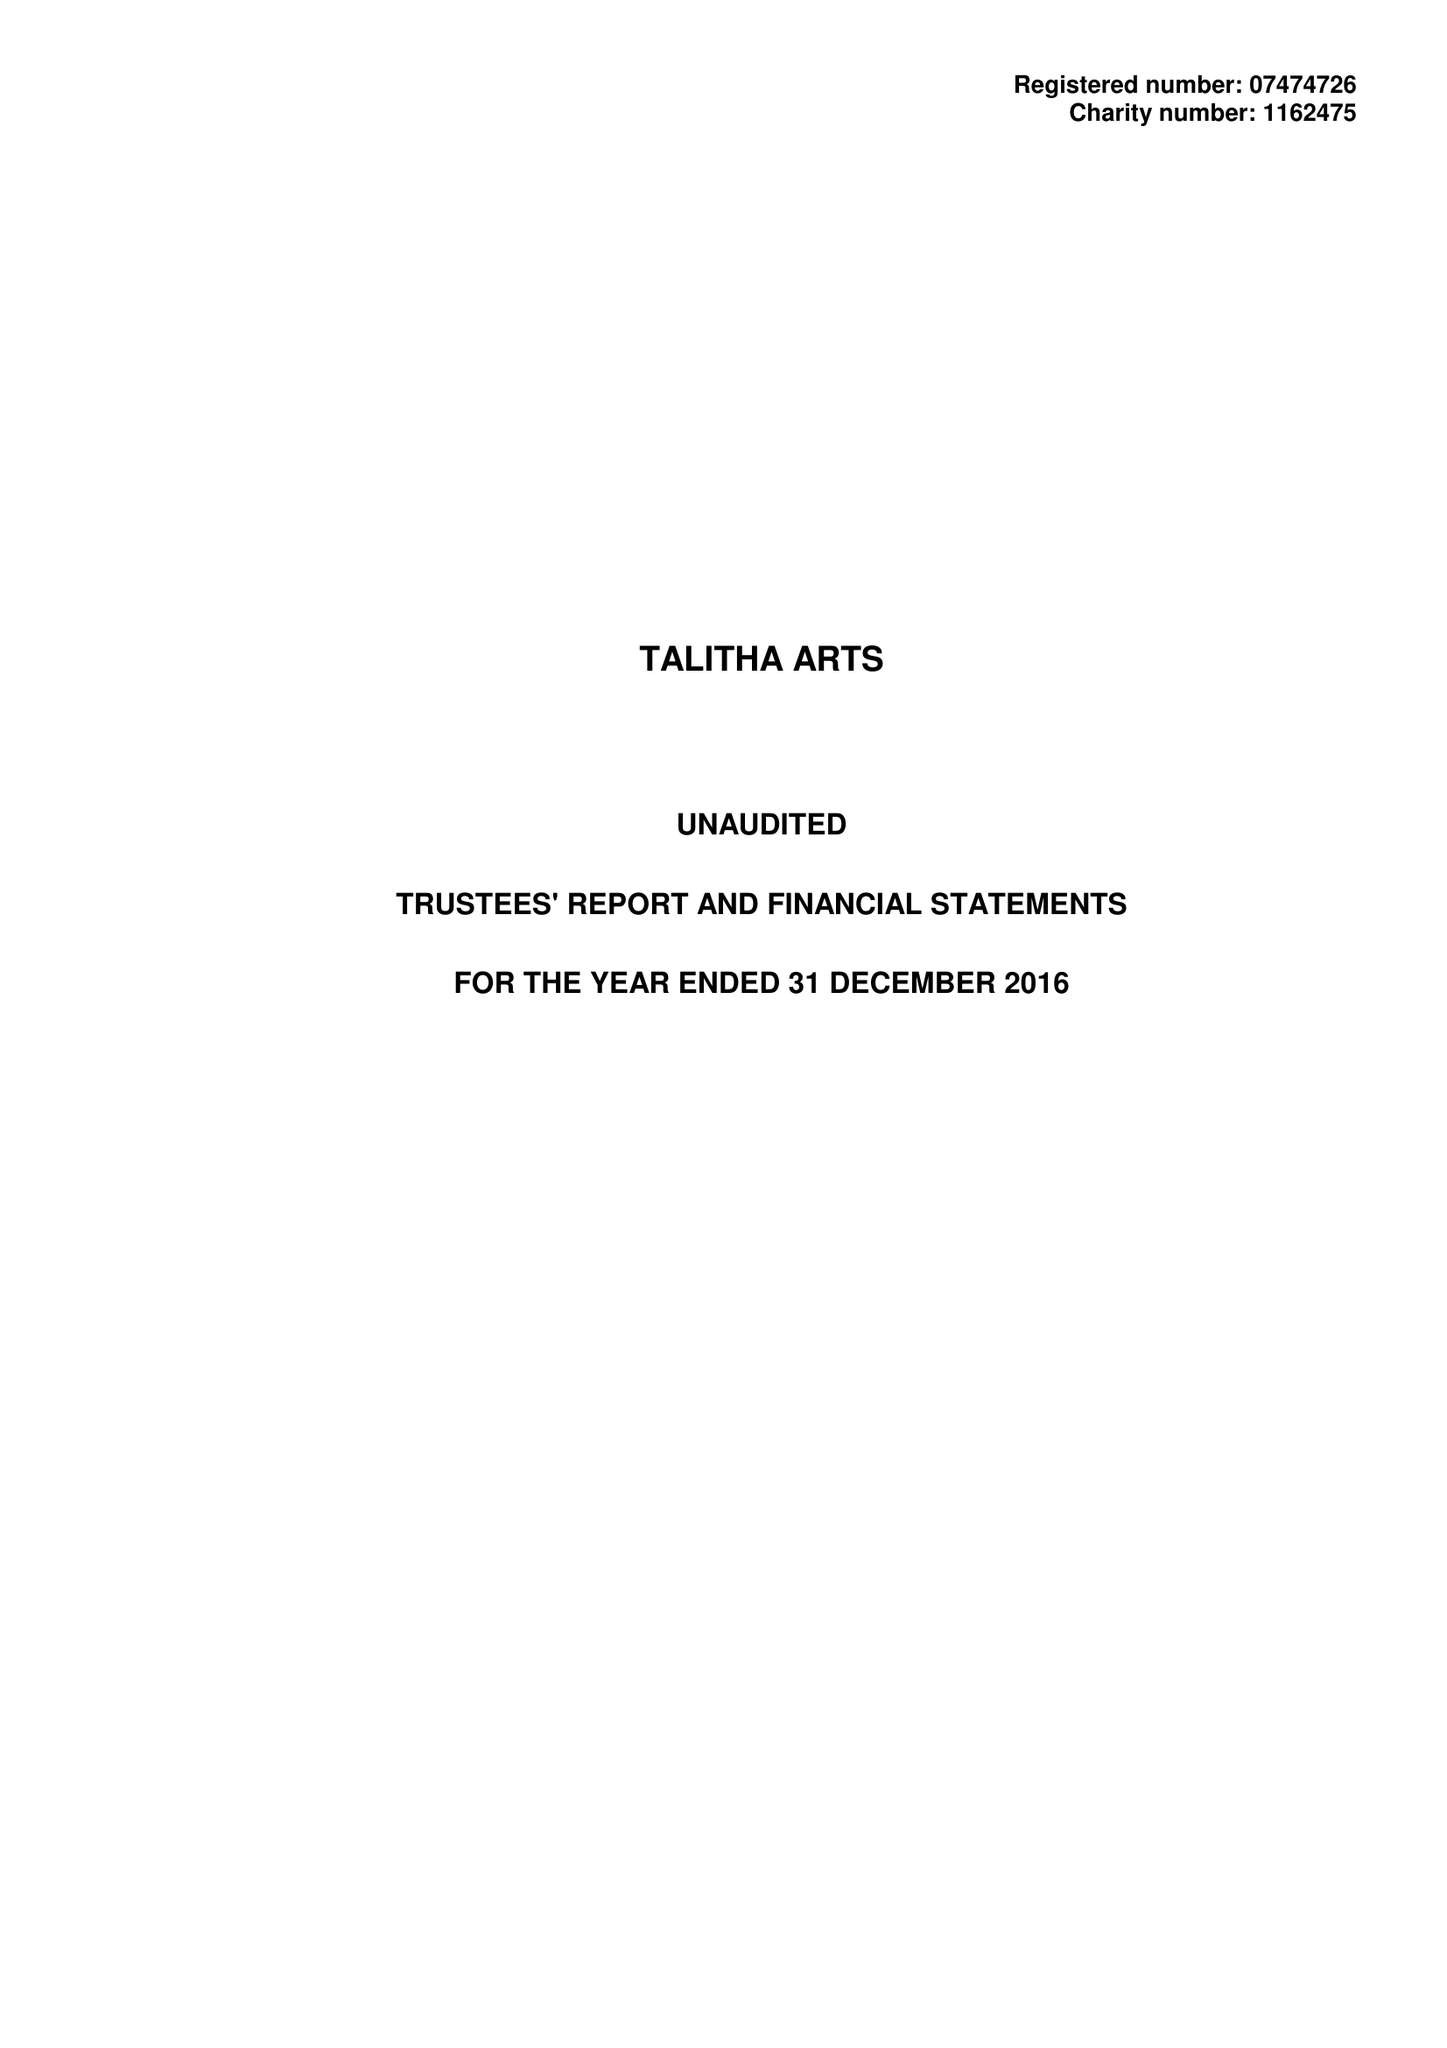What is the value for the address__postcode?
Answer the question using a single word or phrase. TW11 0BQ 